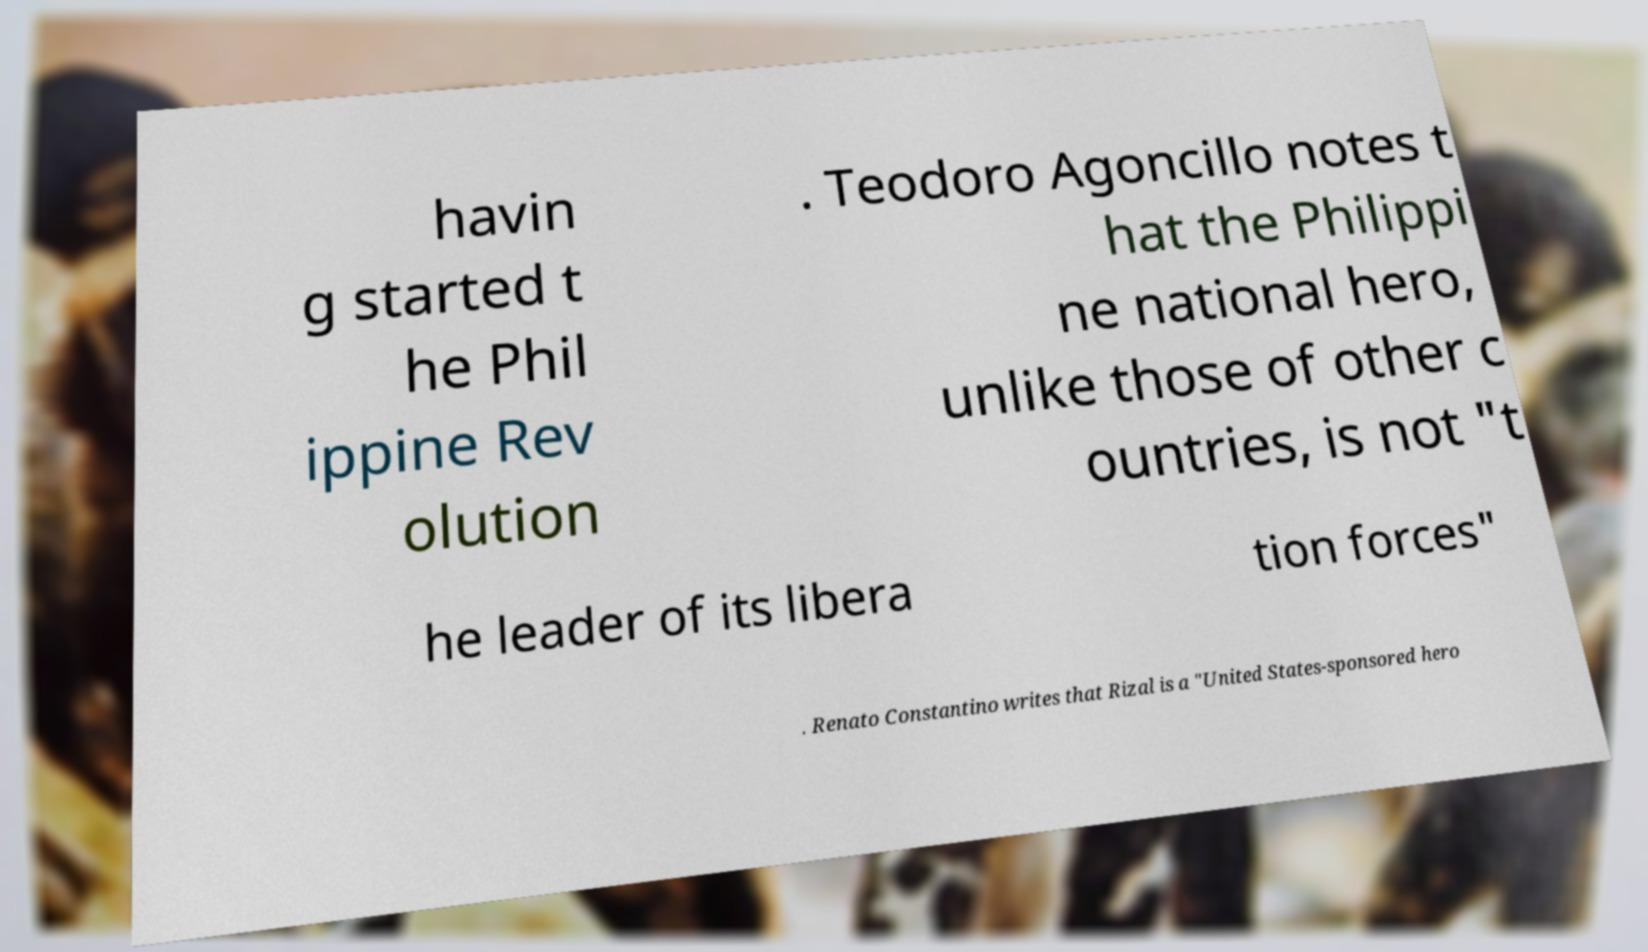Could you extract and type out the text from this image? havin g started t he Phil ippine Rev olution . Teodoro Agoncillo notes t hat the Philippi ne national hero, unlike those of other c ountries, is not "t he leader of its libera tion forces" . Renato Constantino writes that Rizal is a "United States-sponsored hero 